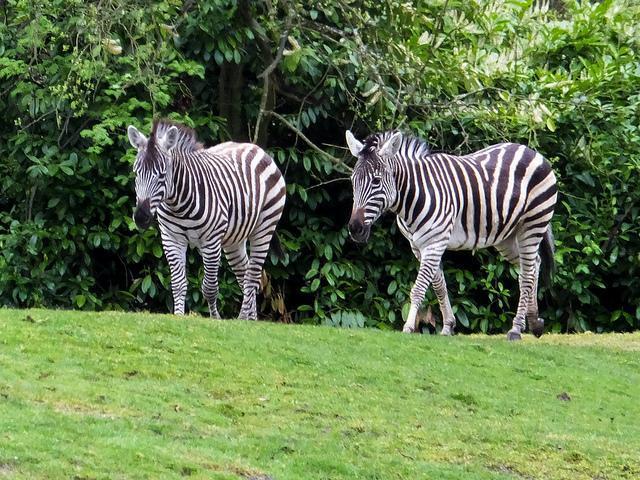How many zebras can be seen?
Give a very brief answer. 2. 